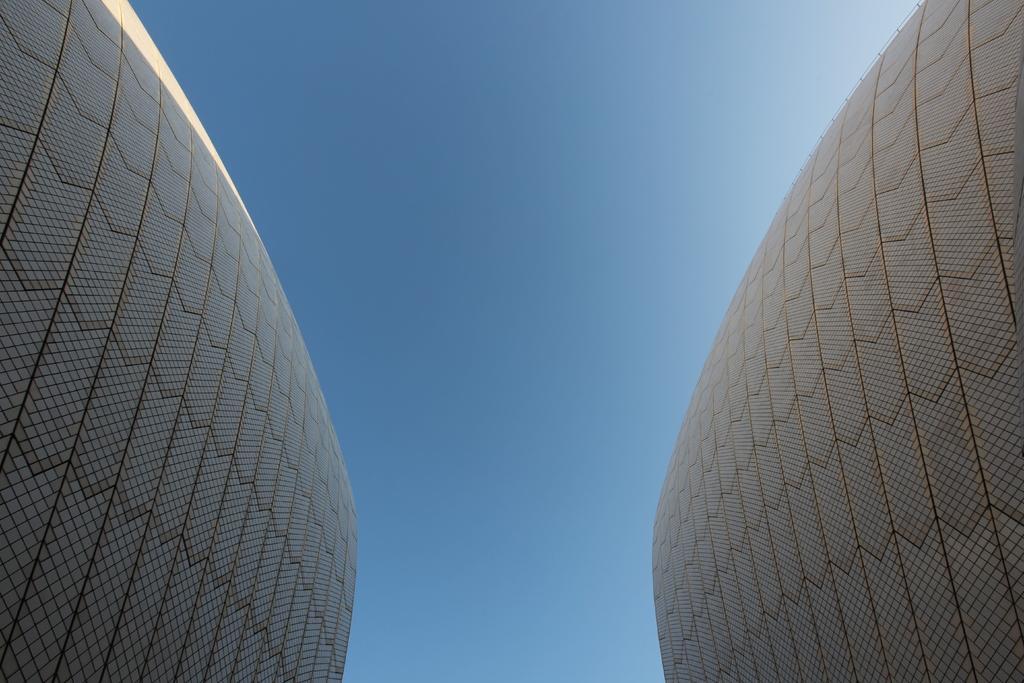Could you give a brief overview of what you see in this image? In the center of the image we can see the sky and walls. 